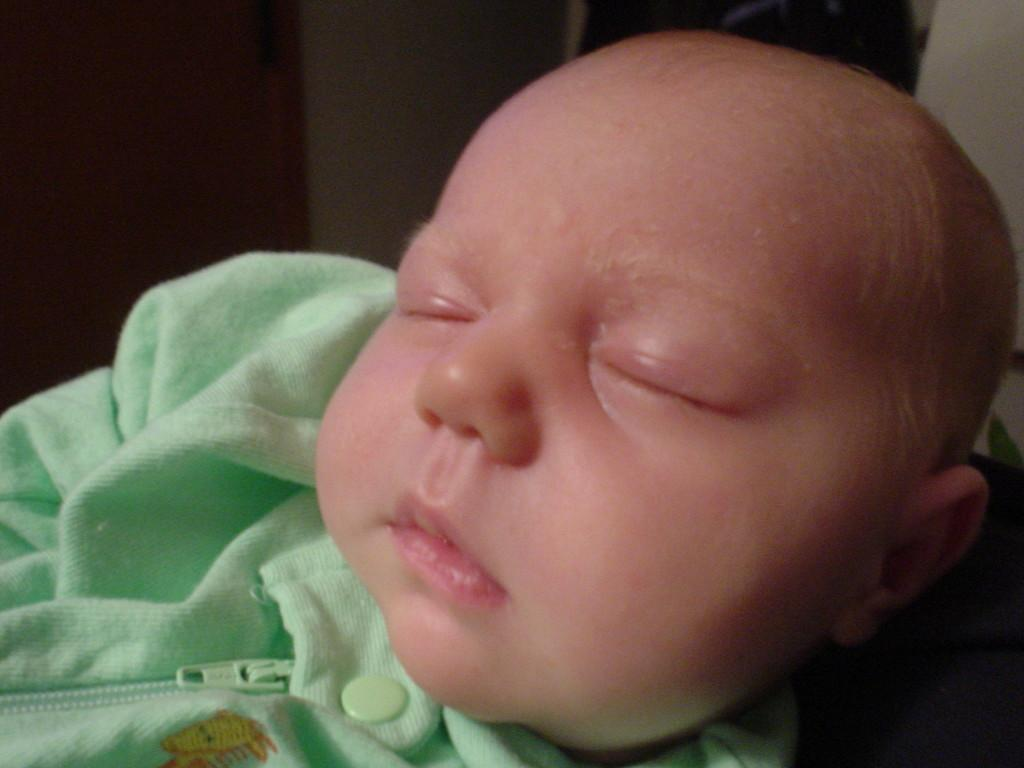What is the main subject of the image? There is a baby in the image. What is the baby doing in the image? The baby is sleeping. What is the baby wearing in the image? The baby is wearing clothes. What color are the clothes the baby is wearing? The clothes are pale green in color. What type of destruction can be seen happening in the image? There is no destruction present in the image; it features a sleeping baby wearing pale green clothes. 